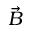Convert formula to latex. <formula><loc_0><loc_0><loc_500><loc_500>\vec { B }</formula> 